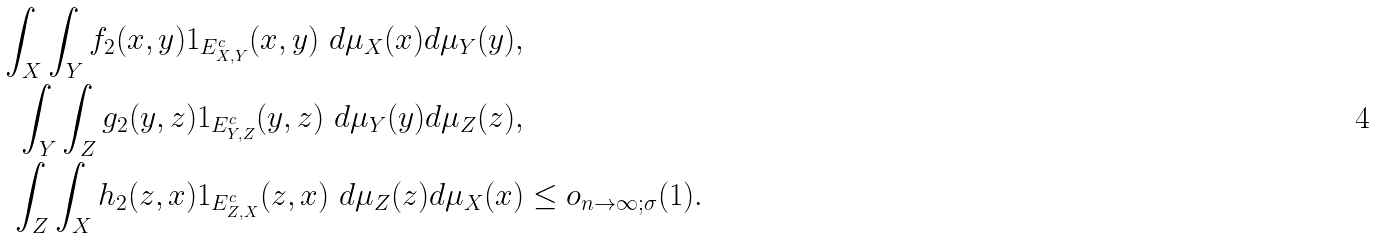<formula> <loc_0><loc_0><loc_500><loc_500>\int _ { X } \int _ { Y } f _ { 2 } ( x , y ) 1 _ { E _ { X , Y } ^ { c } } ( x , y ) \ d \mu _ { X } ( x ) d \mu _ { Y } ( y ) , & \\ \int _ { Y } \int _ { Z } g _ { 2 } ( y , z ) 1 _ { E _ { Y , Z } ^ { c } } ( y , z ) \ d \mu _ { Y } ( y ) d \mu _ { Z } ( z ) , & \\ \int _ { Z } \int _ { X } h _ { 2 } ( z , x ) 1 _ { E _ { Z , X } ^ { c } } ( z , x ) \ d \mu _ { Z } ( z ) d \mu _ { X } ( x ) & \leq o _ { n \to \infty ; \sigma } ( 1 ) .</formula> 